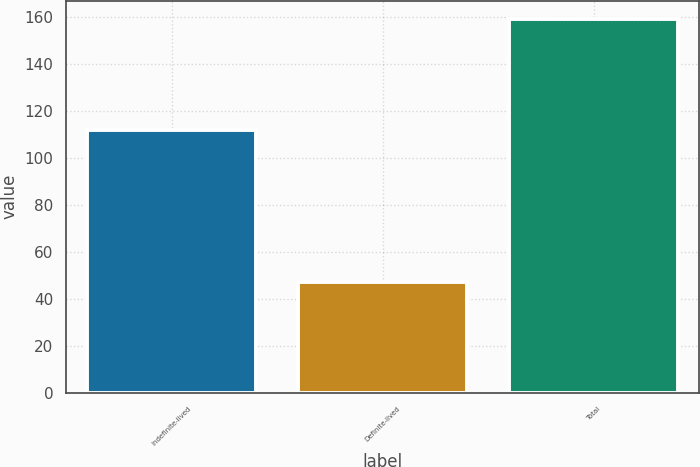<chart> <loc_0><loc_0><loc_500><loc_500><bar_chart><fcel>Indefinite-lived<fcel>Definite-lived<fcel>Total<nl><fcel>112<fcel>47<fcel>159<nl></chart> 